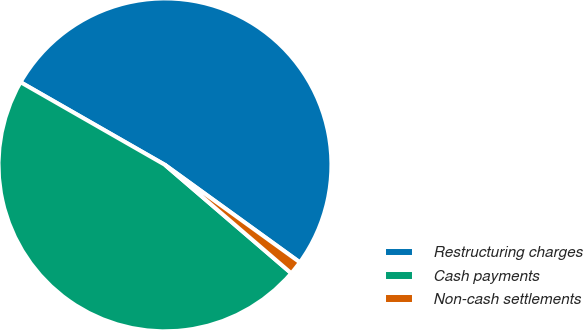Convert chart. <chart><loc_0><loc_0><loc_500><loc_500><pie_chart><fcel>Restructuring charges<fcel>Cash payments<fcel>Non-cash settlements<nl><fcel>51.69%<fcel>46.99%<fcel>1.33%<nl></chart> 